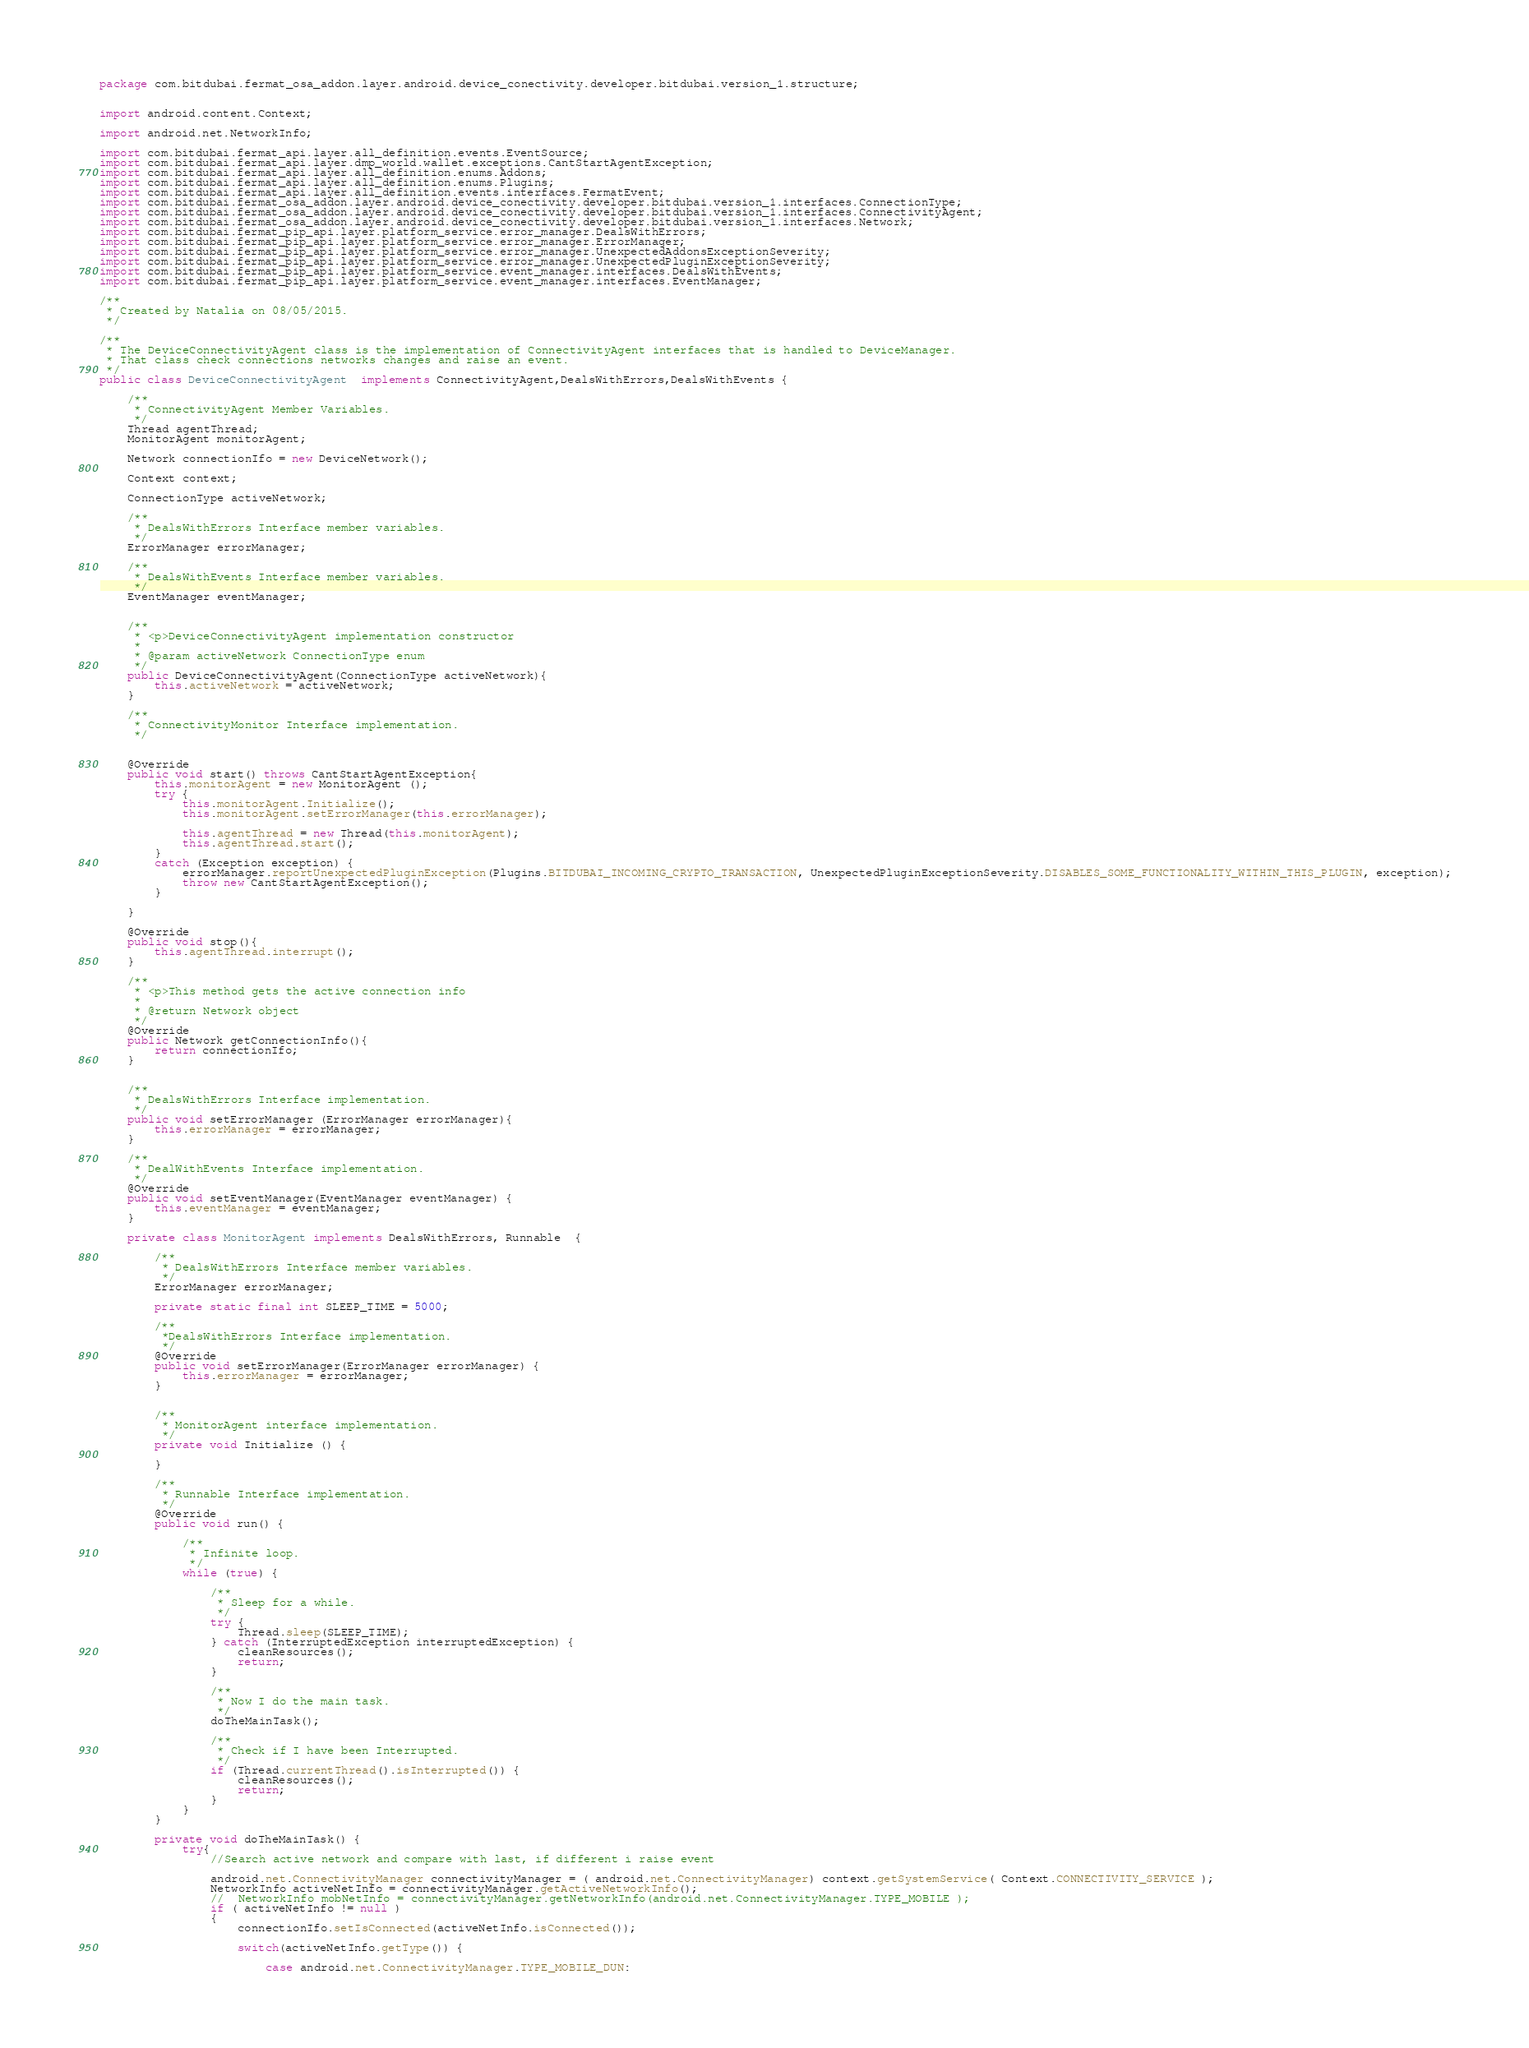<code> <loc_0><loc_0><loc_500><loc_500><_Java_>package com.bitdubai.fermat_osa_addon.layer.android.device_conectivity.developer.bitdubai.version_1.structure;


import android.content.Context;

import android.net.NetworkInfo;

import com.bitdubai.fermat_api.layer.all_definition.events.EventSource;
import com.bitdubai.fermat_api.layer.dmp_world.wallet.exceptions.CantStartAgentException;
import com.bitdubai.fermat_api.layer.all_definition.enums.Addons;
import com.bitdubai.fermat_api.layer.all_definition.enums.Plugins;
import com.bitdubai.fermat_api.layer.all_definition.events.interfaces.FermatEvent;
import com.bitdubai.fermat_osa_addon.layer.android.device_conectivity.developer.bitdubai.version_1.interfaces.ConnectionType;
import com.bitdubai.fermat_osa_addon.layer.android.device_conectivity.developer.bitdubai.version_1.interfaces.ConnectivityAgent;
import com.bitdubai.fermat_osa_addon.layer.android.device_conectivity.developer.bitdubai.version_1.interfaces.Network;
import com.bitdubai.fermat_pip_api.layer.platform_service.error_manager.DealsWithErrors;
import com.bitdubai.fermat_pip_api.layer.platform_service.error_manager.ErrorManager;
import com.bitdubai.fermat_pip_api.layer.platform_service.error_manager.UnexpectedAddonsExceptionSeverity;
import com.bitdubai.fermat_pip_api.layer.platform_service.error_manager.UnexpectedPluginExceptionSeverity;
import com.bitdubai.fermat_pip_api.layer.platform_service.event_manager.interfaces.DealsWithEvents;
import com.bitdubai.fermat_pip_api.layer.platform_service.event_manager.interfaces.EventManager;

/**
 * Created by Natalia on 08/05/2015.
 */

/**
 * The DeviceConnectivityAgent class is the implementation of ConnectivityAgent interfaces that is handled to DeviceManager.
 * That class check connections networks changes and raise an event.
 */
public class DeviceConnectivityAgent  implements ConnectivityAgent,DealsWithErrors,DealsWithEvents {

    /**
     * ConnectivityAgent Member Variables.
     */
    Thread agentThread;
    MonitorAgent monitorAgent;

    Network connectionIfo = new DeviceNetwork();

    Context context;

    ConnectionType activeNetwork;

    /**
     * DealsWithErrors Interface member variables.
     */
    ErrorManager errorManager;

    /**
     * DealsWithEvents Interface member variables.
     */
    EventManager eventManager;


    /**
     * <p>DeviceConnectivityAgent implementation constructor
     *
     * @param activeNetwork ConnectionType enum
     */
    public DeviceConnectivityAgent(ConnectionType activeNetwork){
        this.activeNetwork = activeNetwork;
    }

    /**
     * ConnectivityMonitor Interface implementation.
     */


    @Override
    public void start() throws CantStartAgentException{
        this.monitorAgent = new MonitorAgent ();
        try {
            this.monitorAgent.Initialize();
            this.monitorAgent.setErrorManager(this.errorManager);

            this.agentThread = new Thread(this.monitorAgent);
            this.agentThread.start();
        }
        catch (Exception exception) {
            errorManager.reportUnexpectedPluginException(Plugins.BITDUBAI_INCOMING_CRYPTO_TRANSACTION, UnexpectedPluginExceptionSeverity.DISABLES_SOME_FUNCTIONALITY_WITHIN_THIS_PLUGIN, exception);
            throw new CantStartAgentException();
        }

    }

    @Override
    public void stop(){
        this.agentThread.interrupt();
    }

    /**
     * <p>This method gets the active connection info
     *
     * @return Network object
     */
    @Override
    public Network getConnectionInfo(){
        return connectionIfo;
    }


    /**
     * DealsWithErrors Interface implementation.
     */
    public void setErrorManager (ErrorManager errorManager){
        this.errorManager = errorManager;
    }

    /**
     * DealWithEvents Interface implementation.
     */
    @Override
    public void setEventManager(EventManager eventManager) {
        this.eventManager = eventManager;
    }

    private class MonitorAgent implements DealsWithErrors, Runnable  {

        /**
         * DealsWithErrors Interface member variables.
         */
        ErrorManager errorManager;

        private static final int SLEEP_TIME = 5000;

        /**
         *DealsWithErrors Interface implementation.
         */
        @Override
        public void setErrorManager(ErrorManager errorManager) {
            this.errorManager = errorManager;
        }


        /**
         * MonitorAgent interface implementation.
         */
        private void Initialize () {

        }

        /**
         * Runnable Interface implementation.
         */
        @Override
        public void run() {

            /**
             * Infinite loop.
             */
            while (true) {

                /**
                 * Sleep for a while.
                 */
                try {
                    Thread.sleep(SLEEP_TIME);
                } catch (InterruptedException interruptedException) {
                    cleanResources();
                    return;
                }

                /**
                 * Now I do the main task.
                 */
                doTheMainTask();

                /**
                 * Check if I have been Interrupted.
                 */
                if (Thread.currentThread().isInterrupted()) {
                    cleanResources();
                    return;
                }
            }
        }

        private void doTheMainTask() {
            try{
                //Search active network and compare with last, if different i raise event

                android.net.ConnectivityManager connectivityManager = ( android.net.ConnectivityManager) context.getSystemService( Context.CONNECTIVITY_SERVICE );
                NetworkInfo activeNetInfo = connectivityManager.getActiveNetworkInfo();
                //  NetworkInfo mobNetInfo = connectivityManager.getNetworkInfo(android.net.ConnectivityManager.TYPE_MOBILE );
                if ( activeNetInfo != null )
                {
                    connectionIfo.setIsConnected(activeNetInfo.isConnected());

                    switch(activeNetInfo.getType()) {

                        case android.net.ConnectivityManager.TYPE_MOBILE_DUN:</code> 